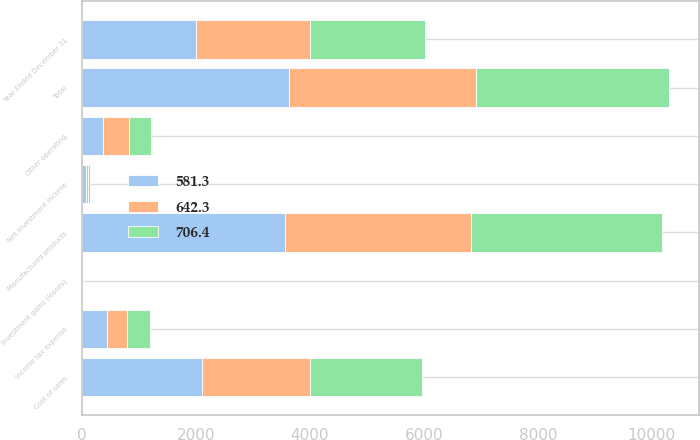Convert chart. <chart><loc_0><loc_0><loc_500><loc_500><stacked_bar_chart><ecel><fcel>Year Ended December 31<fcel>Manufactured products<fcel>Net investment income<fcel>Investment gains (losses)<fcel>Total<fcel>Cost of sales<fcel>Other operating<fcel>Income tax expense<nl><fcel>581.3<fcel>2005<fcel>3567.8<fcel>63.6<fcel>2.1<fcel>3635.3<fcel>2114.4<fcel>369.1<fcel>444.9<nl><fcel>706.4<fcel>2004<fcel>3347.8<fcel>36.6<fcel>1.4<fcel>3385.8<fcel>1965.6<fcel>380.6<fcel>397.3<nl><fcel>642.3<fcel>2003<fcel>3255.6<fcel>39.9<fcel>9.7<fcel>3285.7<fcel>1893.1<fcel>460<fcel>351.2<nl></chart> 